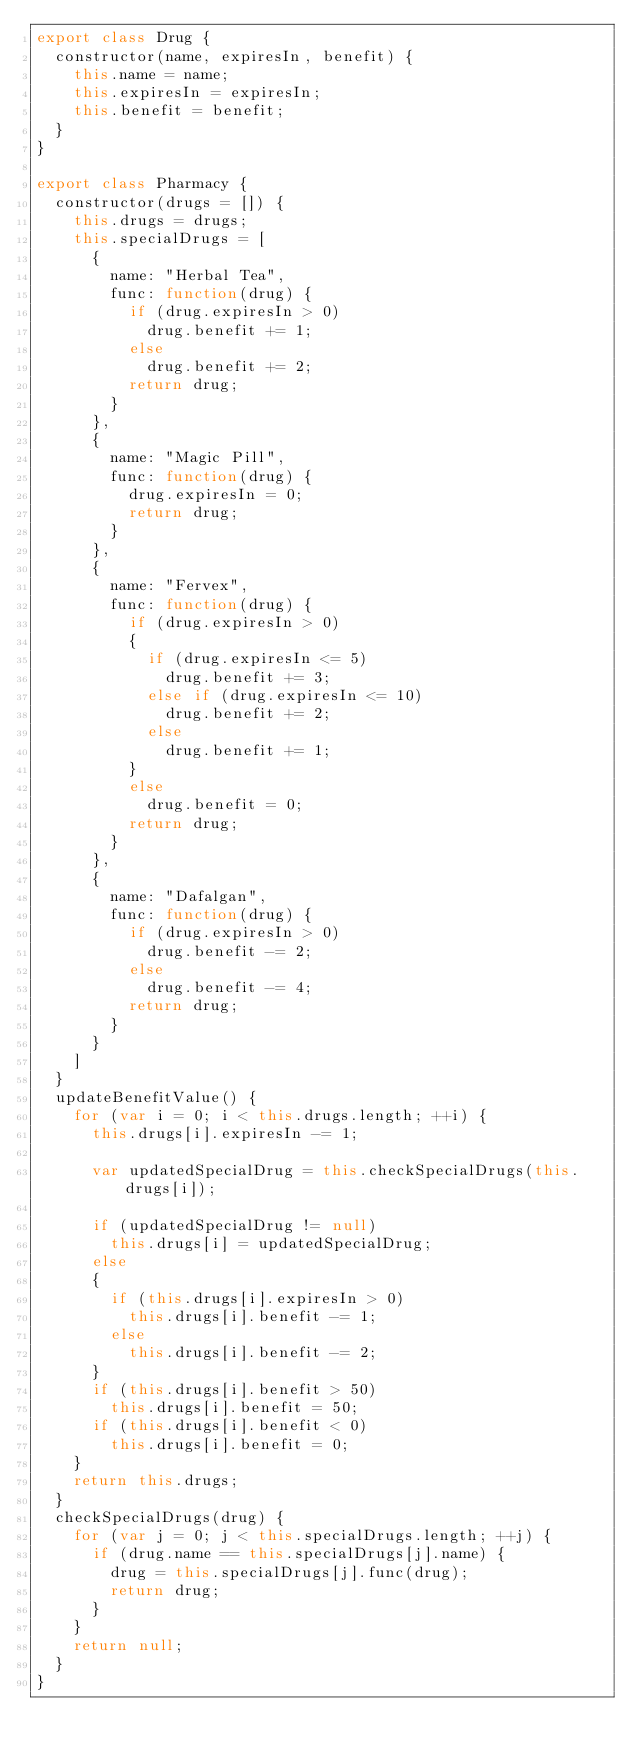<code> <loc_0><loc_0><loc_500><loc_500><_JavaScript_>export class Drug {
  constructor(name, expiresIn, benefit) {
    this.name = name;
    this.expiresIn = expiresIn;
    this.benefit = benefit;
  }
}

export class Pharmacy {
  constructor(drugs = []) {
    this.drugs = drugs;
    this.specialDrugs = [
      {
        name: "Herbal Tea",
        func: function(drug) {
          if (drug.expiresIn > 0)
            drug.benefit += 1;
          else
            drug.benefit += 2;
          return drug;
        }
      },
      {
        name: "Magic Pill",
        func: function(drug) {
          drug.expiresIn = 0;
          return drug;
        }
      },
      {
        name: "Fervex",
        func: function(drug) {
          if (drug.expiresIn > 0)
          {
            if (drug.expiresIn <= 5)
              drug.benefit += 3;
            else if (drug.expiresIn <= 10)
              drug.benefit += 2;
            else
              drug.benefit += 1;
          }
          else
            drug.benefit = 0;
          return drug;
        }
      },
      {
        name: "Dafalgan",
        func: function(drug) {
          if (drug.expiresIn > 0)
            drug.benefit -= 2;
          else
            drug.benefit -= 4;
          return drug;
        }
      }
    ]
  }
  updateBenefitValue() {
    for (var i = 0; i < this.drugs.length; ++i) {
      this.drugs[i].expiresIn -= 1;
      
      var updatedSpecialDrug = this.checkSpecialDrugs(this.drugs[i]);

      if (updatedSpecialDrug != null)
        this.drugs[i] = updatedSpecialDrug;
      else
      {
        if (this.drugs[i].expiresIn > 0)
          this.drugs[i].benefit -= 1;
        else
          this.drugs[i].benefit -= 2;
      }
      if (this.drugs[i].benefit > 50)
        this.drugs[i].benefit = 50;
      if (this.drugs[i].benefit < 0)
        this.drugs[i].benefit = 0;
    }
    return this.drugs;
  }
  checkSpecialDrugs(drug) {
    for (var j = 0; j < this.specialDrugs.length; ++j) {
      if (drug.name == this.specialDrugs[j].name) {
        drug = this.specialDrugs[j].func(drug);
        return drug;
      }
    }
    return null;
  }
}
</code> 